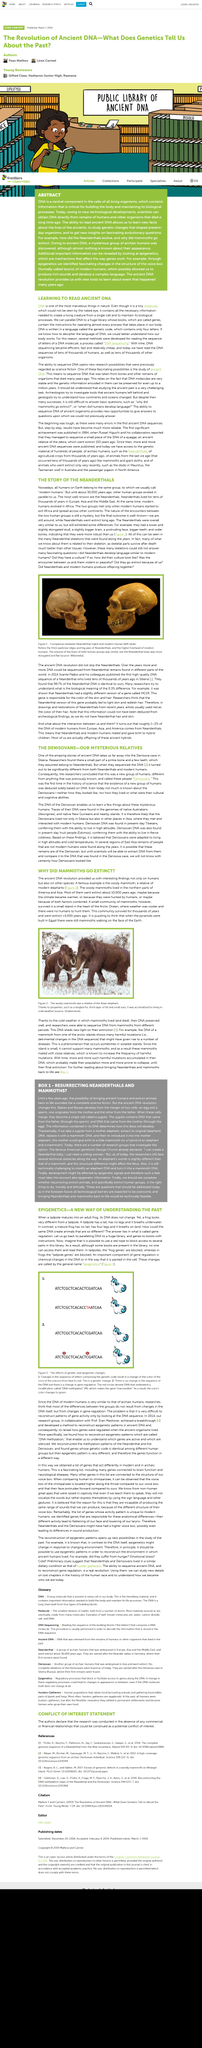Mention a couple of crucial points in this snapshot. The extinct relatives of humans, known as Denisovans, have been identified through DNA analysis. The article's title asks the question of why certain species, such as mammoths, have gone extinct. DNA is written in a language called the genetic code, which consists of a set of instructions that determine the characteristics and function of living organisms. DNA language contains four letters. A small community of mammoths survived for thousands of years and went extinct less than 4,000 years ago, as stated in the article. 